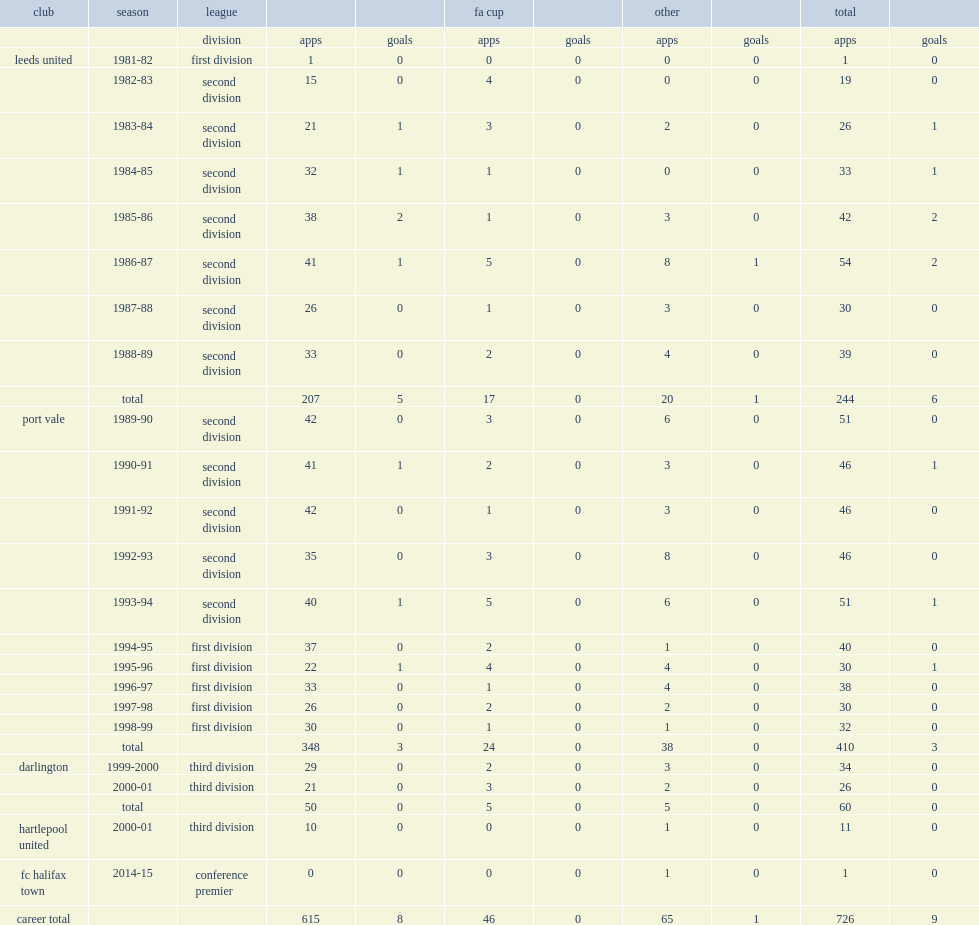How many league and cup appearances did neil aspin spend seven seasons in the second division with the leeds united? 244.0. 